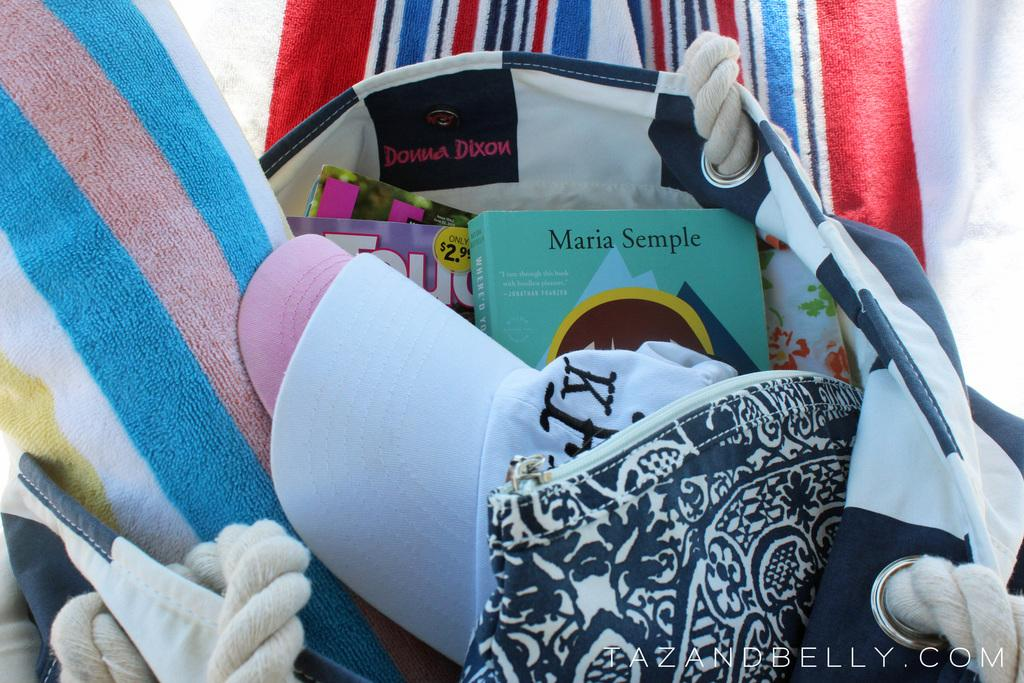What objects are in the foreground of the picture? In the foreground of the picture, there are caps, a small bag, a towel, and books in a bag. Can you describe the contents of the small bag? The small bag contains books. What color is the towel in the foreground of the picture? The towel in the foreground of the picture is not mentioned, but there is another red towel in the background. What is the color of the towel in the background of the picture? The towel in the background of the picture is red. What type of quill is being used to write on the books in the image? There is no quill present in the image; the books are in a bag in the foreground of the picture. Is there any indication of a power source in the image? There is no mention of a power source in the image; it primarily features caps, a small bag, a towel, and books in a bag. 